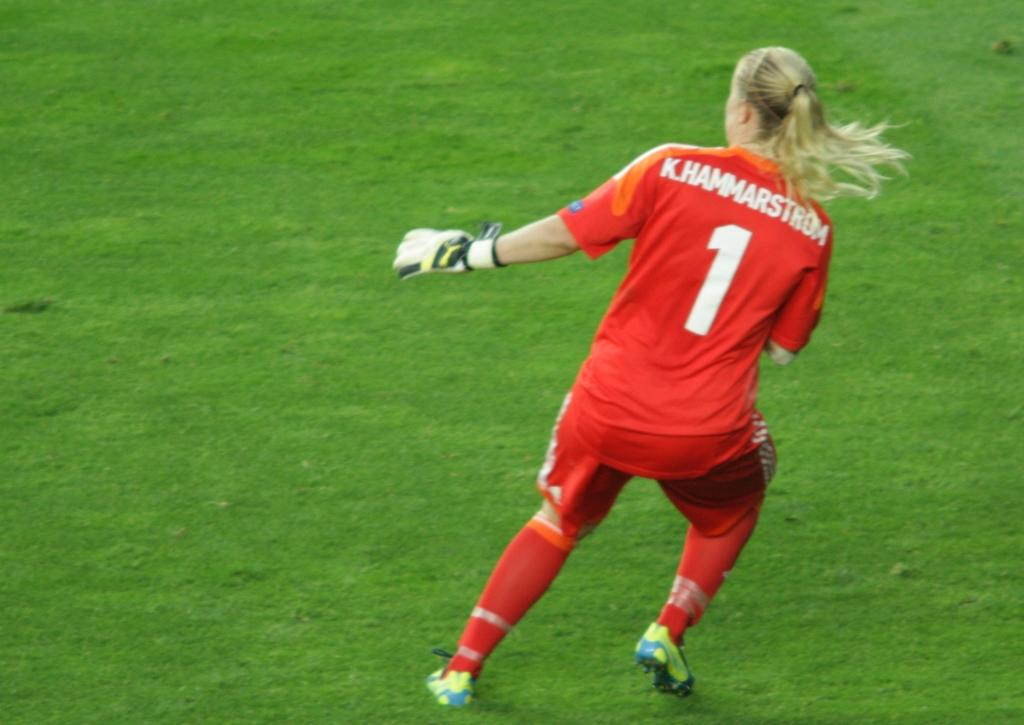<image>
Present a compact description of the photo's key features. Soccer goalie with number one on the back in white on an orange jersey. 